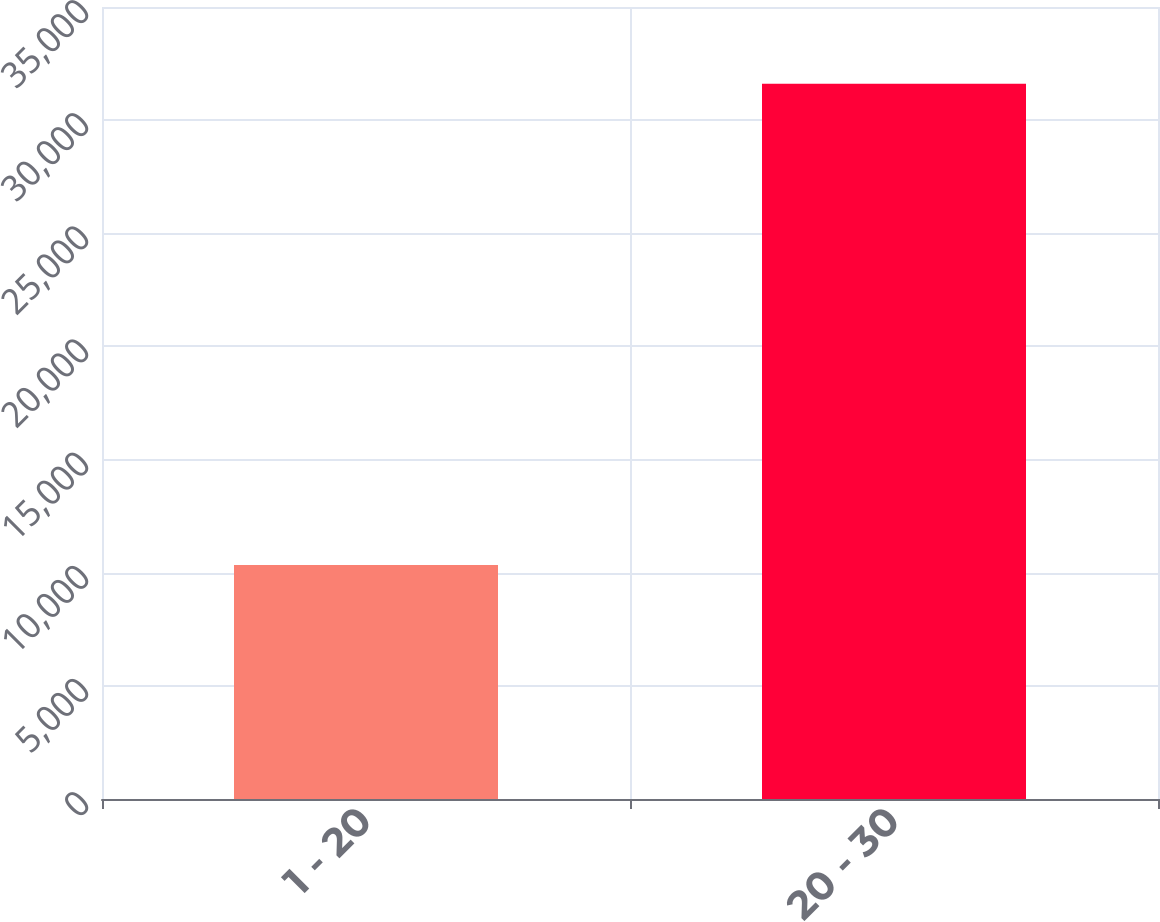Convert chart. <chart><loc_0><loc_0><loc_500><loc_500><bar_chart><fcel>1 - 20<fcel>20 - 30<nl><fcel>10344<fcel>31606<nl></chart> 